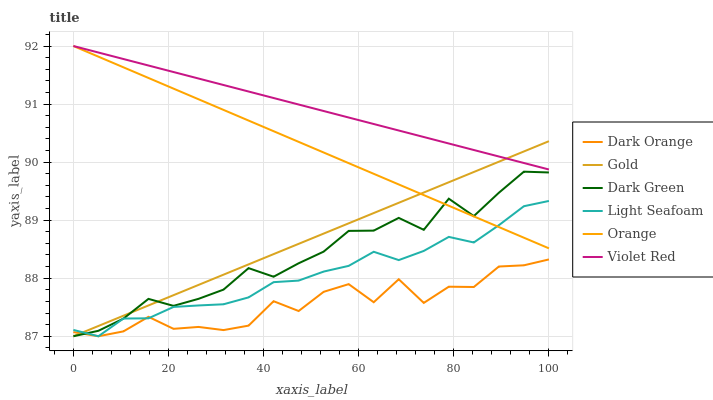Does Dark Orange have the minimum area under the curve?
Answer yes or no. Yes. Does Violet Red have the maximum area under the curve?
Answer yes or no. Yes. Does Gold have the minimum area under the curve?
Answer yes or no. No. Does Gold have the maximum area under the curve?
Answer yes or no. No. Is Orange the smoothest?
Answer yes or no. Yes. Is Dark Orange the roughest?
Answer yes or no. Yes. Is Violet Red the smoothest?
Answer yes or no. No. Is Violet Red the roughest?
Answer yes or no. No. Does Violet Red have the lowest value?
Answer yes or no. No. Does Gold have the highest value?
Answer yes or no. No. Is Dark Orange less than Orange?
Answer yes or no. Yes. Is Violet Red greater than Dark Green?
Answer yes or no. Yes. Does Dark Orange intersect Orange?
Answer yes or no. No. 